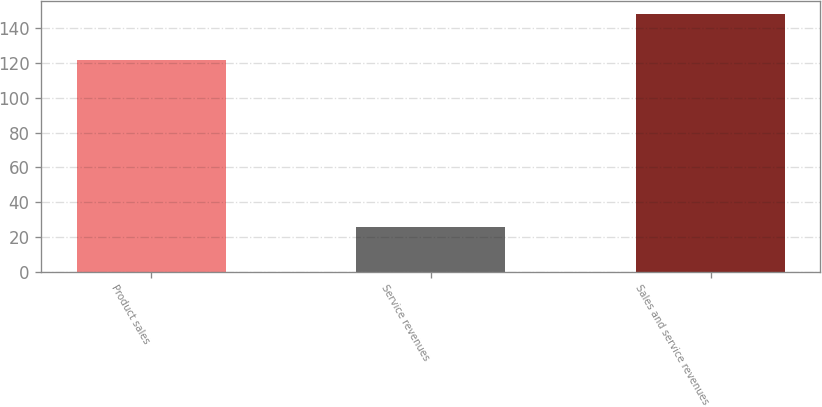Convert chart. <chart><loc_0><loc_0><loc_500><loc_500><bar_chart><fcel>Product sales<fcel>Service revenues<fcel>Sales and service revenues<nl><fcel>122<fcel>26<fcel>148<nl></chart> 